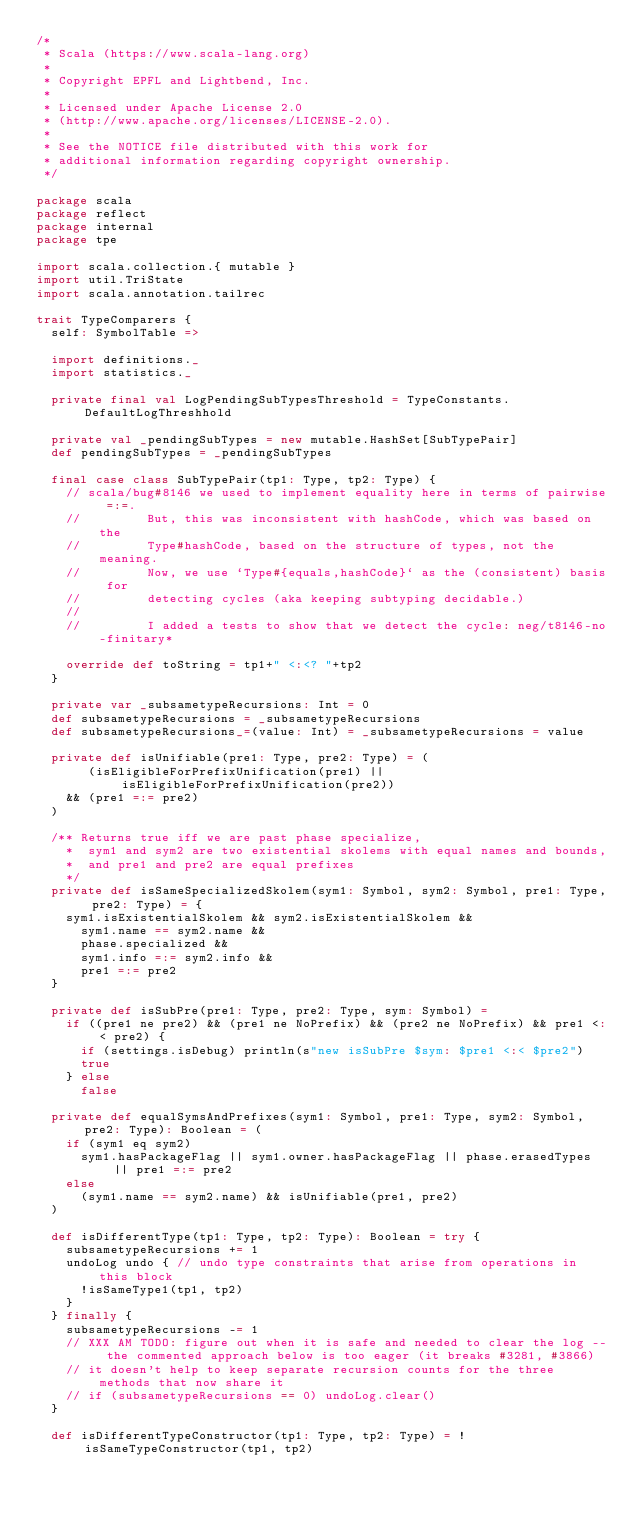Convert code to text. <code><loc_0><loc_0><loc_500><loc_500><_Scala_>/*
 * Scala (https://www.scala-lang.org)
 *
 * Copyright EPFL and Lightbend, Inc.
 *
 * Licensed under Apache License 2.0
 * (http://www.apache.org/licenses/LICENSE-2.0).
 *
 * See the NOTICE file distributed with this work for
 * additional information regarding copyright ownership.
 */

package scala
package reflect
package internal
package tpe

import scala.collection.{ mutable }
import util.TriState
import scala.annotation.tailrec

trait TypeComparers {
  self: SymbolTable =>

  import definitions._
  import statistics._

  private final val LogPendingSubTypesThreshold = TypeConstants.DefaultLogThreshhold

  private val _pendingSubTypes = new mutable.HashSet[SubTypePair]
  def pendingSubTypes = _pendingSubTypes

  final case class SubTypePair(tp1: Type, tp2: Type) {
    // scala/bug#8146 we used to implement equality here in terms of pairwise =:=.
    //         But, this was inconsistent with hashCode, which was based on the
    //         Type#hashCode, based on the structure of types, not the meaning.
    //         Now, we use `Type#{equals,hashCode}` as the (consistent) basis for
    //         detecting cycles (aka keeping subtyping decidable.)
    //
    //         I added a tests to show that we detect the cycle: neg/t8146-no-finitary*

    override def toString = tp1+" <:<? "+tp2
  }

  private var _subsametypeRecursions: Int = 0
  def subsametypeRecursions = _subsametypeRecursions
  def subsametypeRecursions_=(value: Int) = _subsametypeRecursions = value

  private def isUnifiable(pre1: Type, pre2: Type) = (
       (isEligibleForPrefixUnification(pre1) || isEligibleForPrefixUnification(pre2))
    && (pre1 =:= pre2)
  )

  /** Returns true iff we are past phase specialize,
    *  sym1 and sym2 are two existential skolems with equal names and bounds,
    *  and pre1 and pre2 are equal prefixes
    */
  private def isSameSpecializedSkolem(sym1: Symbol, sym2: Symbol, pre1: Type, pre2: Type) = {
    sym1.isExistentialSkolem && sym2.isExistentialSkolem &&
      sym1.name == sym2.name &&
      phase.specialized &&
      sym1.info =:= sym2.info &&
      pre1 =:= pre2
  }

  private def isSubPre(pre1: Type, pre2: Type, sym: Symbol) =
    if ((pre1 ne pre2) && (pre1 ne NoPrefix) && (pre2 ne NoPrefix) && pre1 <:< pre2) {
      if (settings.isDebug) println(s"new isSubPre $sym: $pre1 <:< $pre2")
      true
    } else
      false

  private def equalSymsAndPrefixes(sym1: Symbol, pre1: Type, sym2: Symbol, pre2: Type): Boolean = (
    if (sym1 eq sym2)
      sym1.hasPackageFlag || sym1.owner.hasPackageFlag || phase.erasedTypes || pre1 =:= pre2
    else
      (sym1.name == sym2.name) && isUnifiable(pre1, pre2)
  )

  def isDifferentType(tp1: Type, tp2: Type): Boolean = try {
    subsametypeRecursions += 1
    undoLog undo { // undo type constraints that arise from operations in this block
      !isSameType1(tp1, tp2)
    }
  } finally {
    subsametypeRecursions -= 1
    // XXX AM TODO: figure out when it is safe and needed to clear the log -- the commented approach below is too eager (it breaks #3281, #3866)
    // it doesn't help to keep separate recursion counts for the three methods that now share it
    // if (subsametypeRecursions == 0) undoLog.clear()
  }

  def isDifferentTypeConstructor(tp1: Type, tp2: Type) = !isSameTypeConstructor(tp1, tp2)
</code> 